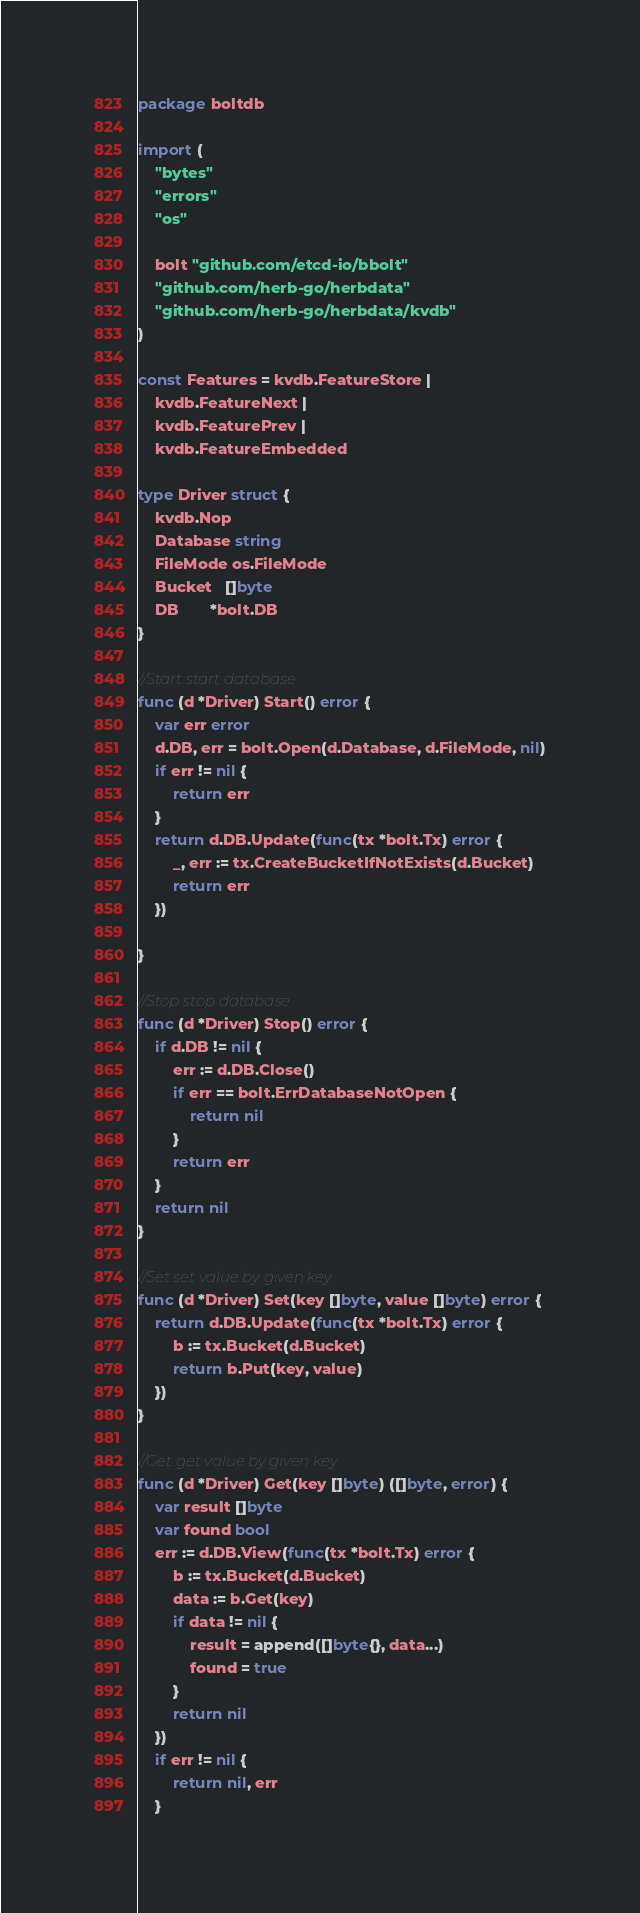<code> <loc_0><loc_0><loc_500><loc_500><_Go_>package boltdb

import (
	"bytes"
	"errors"
	"os"

	bolt "github.com/etcd-io/bbolt"
	"github.com/herb-go/herbdata"
	"github.com/herb-go/herbdata/kvdb"
)

const Features = kvdb.FeatureStore |
	kvdb.FeatureNext |
	kvdb.FeaturePrev |
	kvdb.FeatureEmbedded

type Driver struct {
	kvdb.Nop
	Database string
	FileMode os.FileMode
	Bucket   []byte
	DB       *bolt.DB
}

//Start start database
func (d *Driver) Start() error {
	var err error
	d.DB, err = bolt.Open(d.Database, d.FileMode, nil)
	if err != nil {
		return err
	}
	return d.DB.Update(func(tx *bolt.Tx) error {
		_, err := tx.CreateBucketIfNotExists(d.Bucket)
		return err
	})

}

//Stop stop database
func (d *Driver) Stop() error {
	if d.DB != nil {
		err := d.DB.Close()
		if err == bolt.ErrDatabaseNotOpen {
			return nil
		}
		return err
	}
	return nil
}

//Set set value by given key
func (d *Driver) Set(key []byte, value []byte) error {
	return d.DB.Update(func(tx *bolt.Tx) error {
		b := tx.Bucket(d.Bucket)
		return b.Put(key, value)
	})
}

//Get get value by given key
func (d *Driver) Get(key []byte) ([]byte, error) {
	var result []byte
	var found bool
	err := d.DB.View(func(tx *bolt.Tx) error {
		b := tx.Bucket(d.Bucket)
		data := b.Get(key)
		if data != nil {
			result = append([]byte{}, data...)
			found = true
		}
		return nil
	})
	if err != nil {
		return nil, err
	}</code> 